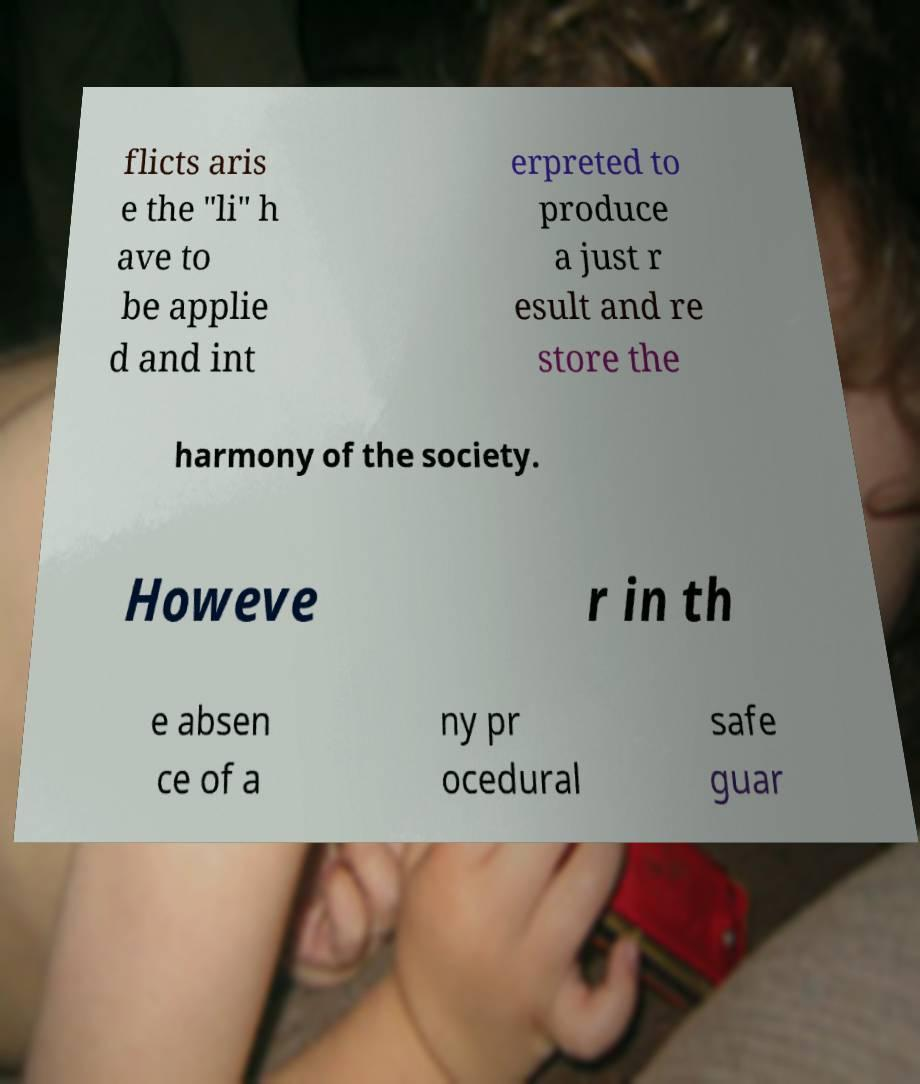There's text embedded in this image that I need extracted. Can you transcribe it verbatim? flicts aris e the "li" h ave to be applie d and int erpreted to produce a just r esult and re store the harmony of the society. Howeve r in th e absen ce of a ny pr ocedural safe guar 